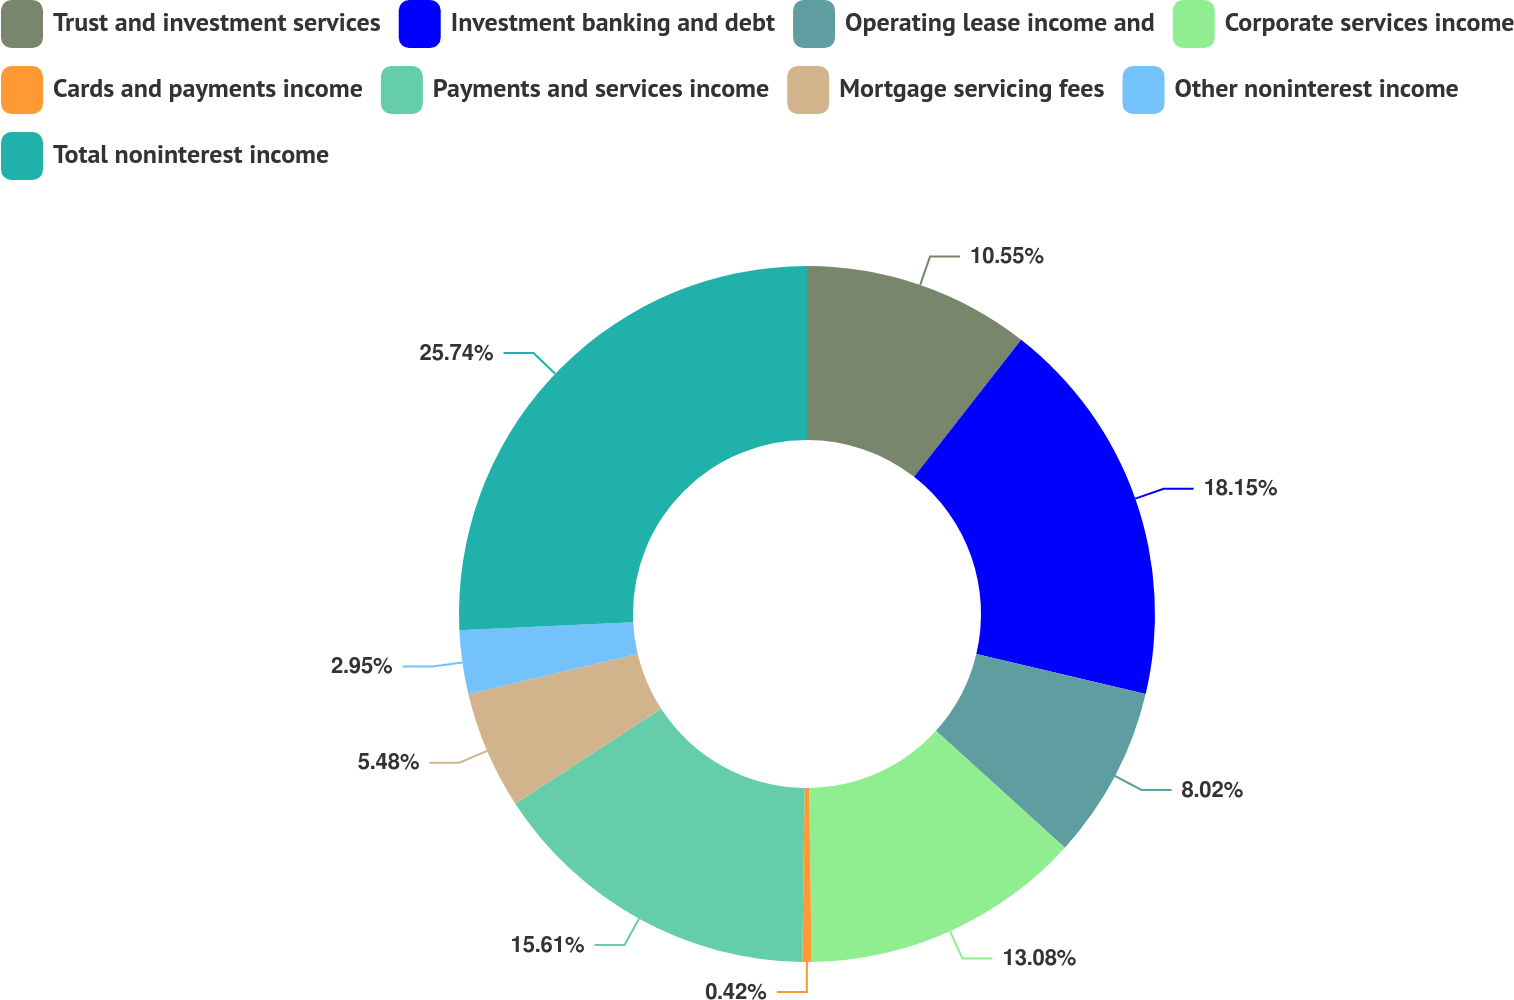<chart> <loc_0><loc_0><loc_500><loc_500><pie_chart><fcel>Trust and investment services<fcel>Investment banking and debt<fcel>Operating lease income and<fcel>Corporate services income<fcel>Cards and payments income<fcel>Payments and services income<fcel>Mortgage servicing fees<fcel>Other noninterest income<fcel>Total noninterest income<nl><fcel>10.55%<fcel>18.15%<fcel>8.02%<fcel>13.08%<fcel>0.42%<fcel>15.61%<fcel>5.48%<fcel>2.95%<fcel>25.75%<nl></chart> 